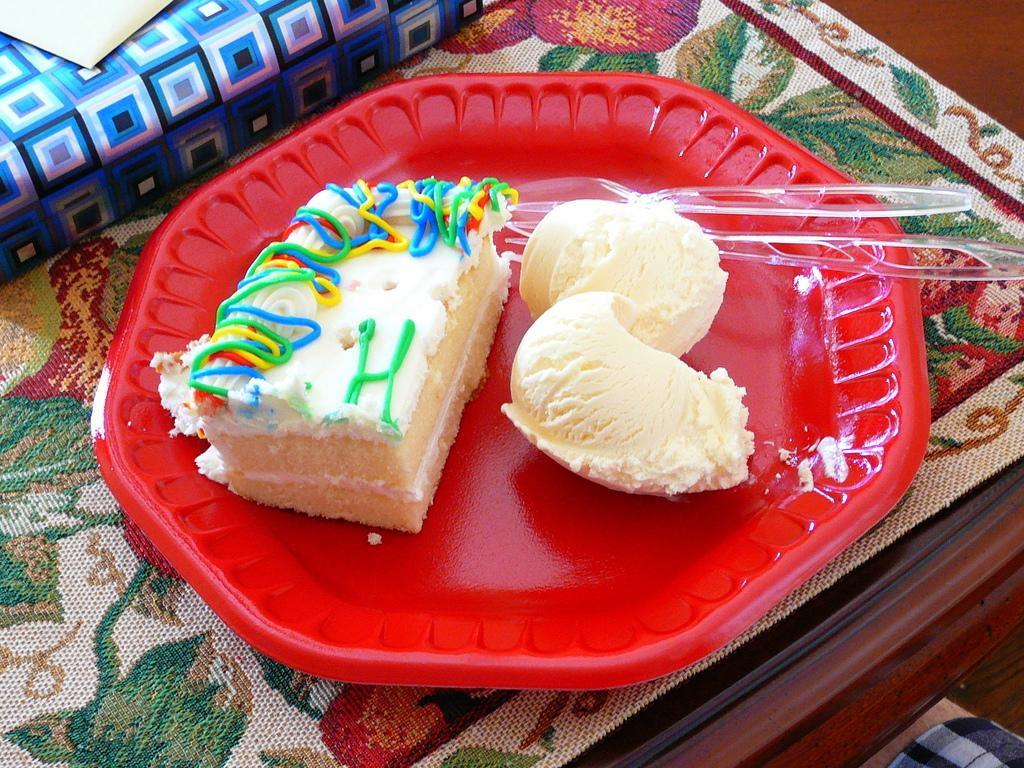What type of food can be seen in the image? There is a pastry in the image. What accompanies the pastry on the plate? There are ice-cream scoops in the image. What color is the plate that holds the pastry and ice-cream scoops? The plate is red in color. What is present on the table to protect it from heat or spills? There is a table mat on the table. What material is the table made of? The table is made of wood. How many babies are crawling under the table in the image? There are no babies present in the image; it only shows a plate with a pastry and ice-cream scoops, a red plate, a table mat, and a wooden table. 